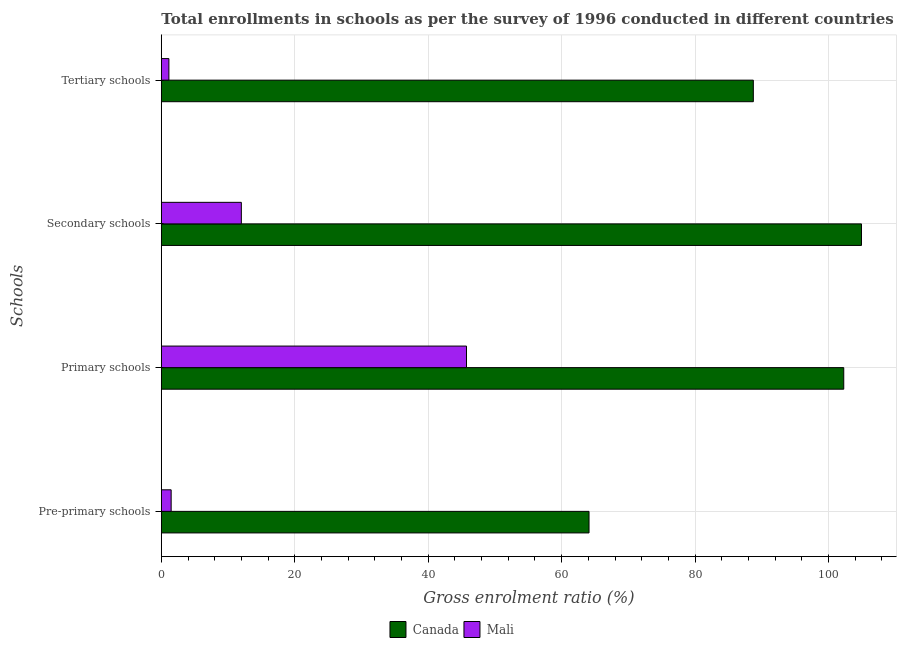How many different coloured bars are there?
Provide a succinct answer. 2. Are the number of bars per tick equal to the number of legend labels?
Give a very brief answer. Yes. How many bars are there on the 3rd tick from the bottom?
Provide a short and direct response. 2. What is the label of the 2nd group of bars from the top?
Your answer should be very brief. Secondary schools. What is the gross enrolment ratio in pre-primary schools in Mali?
Your answer should be compact. 1.47. Across all countries, what is the maximum gross enrolment ratio in tertiary schools?
Offer a very short reply. 88.72. Across all countries, what is the minimum gross enrolment ratio in tertiary schools?
Provide a succinct answer. 1.14. In which country was the gross enrolment ratio in pre-primary schools maximum?
Offer a very short reply. Canada. In which country was the gross enrolment ratio in pre-primary schools minimum?
Provide a short and direct response. Mali. What is the total gross enrolment ratio in secondary schools in the graph?
Your answer should be very brief. 116.92. What is the difference between the gross enrolment ratio in pre-primary schools in Mali and that in Canada?
Your answer should be compact. -62.62. What is the difference between the gross enrolment ratio in secondary schools in Mali and the gross enrolment ratio in pre-primary schools in Canada?
Keep it short and to the point. -52.1. What is the average gross enrolment ratio in tertiary schools per country?
Provide a short and direct response. 44.93. What is the difference between the gross enrolment ratio in pre-primary schools and gross enrolment ratio in tertiary schools in Mali?
Provide a short and direct response. 0.34. In how many countries, is the gross enrolment ratio in secondary schools greater than 64 %?
Your response must be concise. 1. What is the ratio of the gross enrolment ratio in pre-primary schools in Mali to that in Canada?
Offer a very short reply. 0.02. What is the difference between the highest and the second highest gross enrolment ratio in tertiary schools?
Ensure brevity in your answer.  87.59. What is the difference between the highest and the lowest gross enrolment ratio in pre-primary schools?
Provide a short and direct response. 62.62. Is the sum of the gross enrolment ratio in secondary schools in Canada and Mali greater than the maximum gross enrolment ratio in primary schools across all countries?
Your answer should be compact. Yes. Is it the case that in every country, the sum of the gross enrolment ratio in primary schools and gross enrolment ratio in secondary schools is greater than the sum of gross enrolment ratio in pre-primary schools and gross enrolment ratio in tertiary schools?
Offer a terse response. No. What does the 2nd bar from the top in Pre-primary schools represents?
Your answer should be compact. Canada. What does the 1st bar from the bottom in Primary schools represents?
Offer a terse response. Canada. Is it the case that in every country, the sum of the gross enrolment ratio in pre-primary schools and gross enrolment ratio in primary schools is greater than the gross enrolment ratio in secondary schools?
Make the answer very short. Yes. How many bars are there?
Your answer should be compact. 8. Are all the bars in the graph horizontal?
Ensure brevity in your answer.  Yes. Are the values on the major ticks of X-axis written in scientific E-notation?
Your answer should be very brief. No. Does the graph contain any zero values?
Give a very brief answer. No. Does the graph contain grids?
Your answer should be compact. Yes. Where does the legend appear in the graph?
Make the answer very short. Bottom center. How many legend labels are there?
Your answer should be compact. 2. How are the legend labels stacked?
Keep it short and to the point. Horizontal. What is the title of the graph?
Your response must be concise. Total enrollments in schools as per the survey of 1996 conducted in different countries. Does "High income: OECD" appear as one of the legend labels in the graph?
Keep it short and to the point. No. What is the label or title of the Y-axis?
Keep it short and to the point. Schools. What is the Gross enrolment ratio (%) of Canada in Pre-primary schools?
Give a very brief answer. 64.1. What is the Gross enrolment ratio (%) of Mali in Pre-primary schools?
Keep it short and to the point. 1.47. What is the Gross enrolment ratio (%) in Canada in Primary schools?
Your answer should be compact. 102.27. What is the Gross enrolment ratio (%) of Mali in Primary schools?
Your answer should be compact. 45.74. What is the Gross enrolment ratio (%) of Canada in Secondary schools?
Offer a terse response. 104.93. What is the Gross enrolment ratio (%) of Mali in Secondary schools?
Provide a short and direct response. 11.99. What is the Gross enrolment ratio (%) in Canada in Tertiary schools?
Your response must be concise. 88.72. What is the Gross enrolment ratio (%) of Mali in Tertiary schools?
Give a very brief answer. 1.14. Across all Schools, what is the maximum Gross enrolment ratio (%) of Canada?
Your answer should be compact. 104.93. Across all Schools, what is the maximum Gross enrolment ratio (%) in Mali?
Your answer should be compact. 45.74. Across all Schools, what is the minimum Gross enrolment ratio (%) in Canada?
Offer a terse response. 64.1. Across all Schools, what is the minimum Gross enrolment ratio (%) of Mali?
Ensure brevity in your answer.  1.14. What is the total Gross enrolment ratio (%) in Canada in the graph?
Your response must be concise. 360.02. What is the total Gross enrolment ratio (%) in Mali in the graph?
Provide a short and direct response. 60.34. What is the difference between the Gross enrolment ratio (%) in Canada in Pre-primary schools and that in Primary schools?
Your response must be concise. -38.17. What is the difference between the Gross enrolment ratio (%) of Mali in Pre-primary schools and that in Primary schools?
Your answer should be very brief. -44.26. What is the difference between the Gross enrolment ratio (%) in Canada in Pre-primary schools and that in Secondary schools?
Your answer should be very brief. -40.83. What is the difference between the Gross enrolment ratio (%) of Mali in Pre-primary schools and that in Secondary schools?
Provide a succinct answer. -10.52. What is the difference between the Gross enrolment ratio (%) of Canada in Pre-primary schools and that in Tertiary schools?
Offer a terse response. -24.62. What is the difference between the Gross enrolment ratio (%) in Mali in Pre-primary schools and that in Tertiary schools?
Make the answer very short. 0.34. What is the difference between the Gross enrolment ratio (%) in Canada in Primary schools and that in Secondary schools?
Offer a very short reply. -2.66. What is the difference between the Gross enrolment ratio (%) of Mali in Primary schools and that in Secondary schools?
Ensure brevity in your answer.  33.74. What is the difference between the Gross enrolment ratio (%) of Canada in Primary schools and that in Tertiary schools?
Offer a very short reply. 13.55. What is the difference between the Gross enrolment ratio (%) of Mali in Primary schools and that in Tertiary schools?
Your answer should be very brief. 44.6. What is the difference between the Gross enrolment ratio (%) in Canada in Secondary schools and that in Tertiary schools?
Your answer should be very brief. 16.21. What is the difference between the Gross enrolment ratio (%) of Mali in Secondary schools and that in Tertiary schools?
Provide a short and direct response. 10.86. What is the difference between the Gross enrolment ratio (%) in Canada in Pre-primary schools and the Gross enrolment ratio (%) in Mali in Primary schools?
Provide a succinct answer. 18.36. What is the difference between the Gross enrolment ratio (%) in Canada in Pre-primary schools and the Gross enrolment ratio (%) in Mali in Secondary schools?
Your answer should be compact. 52.1. What is the difference between the Gross enrolment ratio (%) in Canada in Pre-primary schools and the Gross enrolment ratio (%) in Mali in Tertiary schools?
Offer a very short reply. 62.96. What is the difference between the Gross enrolment ratio (%) of Canada in Primary schools and the Gross enrolment ratio (%) of Mali in Secondary schools?
Ensure brevity in your answer.  90.28. What is the difference between the Gross enrolment ratio (%) of Canada in Primary schools and the Gross enrolment ratio (%) of Mali in Tertiary schools?
Your answer should be compact. 101.14. What is the difference between the Gross enrolment ratio (%) in Canada in Secondary schools and the Gross enrolment ratio (%) in Mali in Tertiary schools?
Make the answer very short. 103.79. What is the average Gross enrolment ratio (%) of Canada per Schools?
Ensure brevity in your answer.  90. What is the average Gross enrolment ratio (%) of Mali per Schools?
Provide a short and direct response. 15.08. What is the difference between the Gross enrolment ratio (%) of Canada and Gross enrolment ratio (%) of Mali in Pre-primary schools?
Make the answer very short. 62.62. What is the difference between the Gross enrolment ratio (%) in Canada and Gross enrolment ratio (%) in Mali in Primary schools?
Provide a succinct answer. 56.54. What is the difference between the Gross enrolment ratio (%) of Canada and Gross enrolment ratio (%) of Mali in Secondary schools?
Provide a succinct answer. 92.94. What is the difference between the Gross enrolment ratio (%) of Canada and Gross enrolment ratio (%) of Mali in Tertiary schools?
Make the answer very short. 87.59. What is the ratio of the Gross enrolment ratio (%) of Canada in Pre-primary schools to that in Primary schools?
Make the answer very short. 0.63. What is the ratio of the Gross enrolment ratio (%) in Mali in Pre-primary schools to that in Primary schools?
Provide a succinct answer. 0.03. What is the ratio of the Gross enrolment ratio (%) of Canada in Pre-primary schools to that in Secondary schools?
Provide a short and direct response. 0.61. What is the ratio of the Gross enrolment ratio (%) of Mali in Pre-primary schools to that in Secondary schools?
Your answer should be compact. 0.12. What is the ratio of the Gross enrolment ratio (%) of Canada in Pre-primary schools to that in Tertiary schools?
Offer a terse response. 0.72. What is the ratio of the Gross enrolment ratio (%) in Mali in Pre-primary schools to that in Tertiary schools?
Provide a short and direct response. 1.3. What is the ratio of the Gross enrolment ratio (%) in Canada in Primary schools to that in Secondary schools?
Your response must be concise. 0.97. What is the ratio of the Gross enrolment ratio (%) in Mali in Primary schools to that in Secondary schools?
Ensure brevity in your answer.  3.81. What is the ratio of the Gross enrolment ratio (%) of Canada in Primary schools to that in Tertiary schools?
Provide a succinct answer. 1.15. What is the ratio of the Gross enrolment ratio (%) of Mali in Primary schools to that in Tertiary schools?
Offer a very short reply. 40.29. What is the ratio of the Gross enrolment ratio (%) in Canada in Secondary schools to that in Tertiary schools?
Your answer should be compact. 1.18. What is the ratio of the Gross enrolment ratio (%) of Mali in Secondary schools to that in Tertiary schools?
Offer a very short reply. 10.57. What is the difference between the highest and the second highest Gross enrolment ratio (%) in Canada?
Provide a short and direct response. 2.66. What is the difference between the highest and the second highest Gross enrolment ratio (%) in Mali?
Make the answer very short. 33.74. What is the difference between the highest and the lowest Gross enrolment ratio (%) of Canada?
Keep it short and to the point. 40.83. What is the difference between the highest and the lowest Gross enrolment ratio (%) of Mali?
Keep it short and to the point. 44.6. 